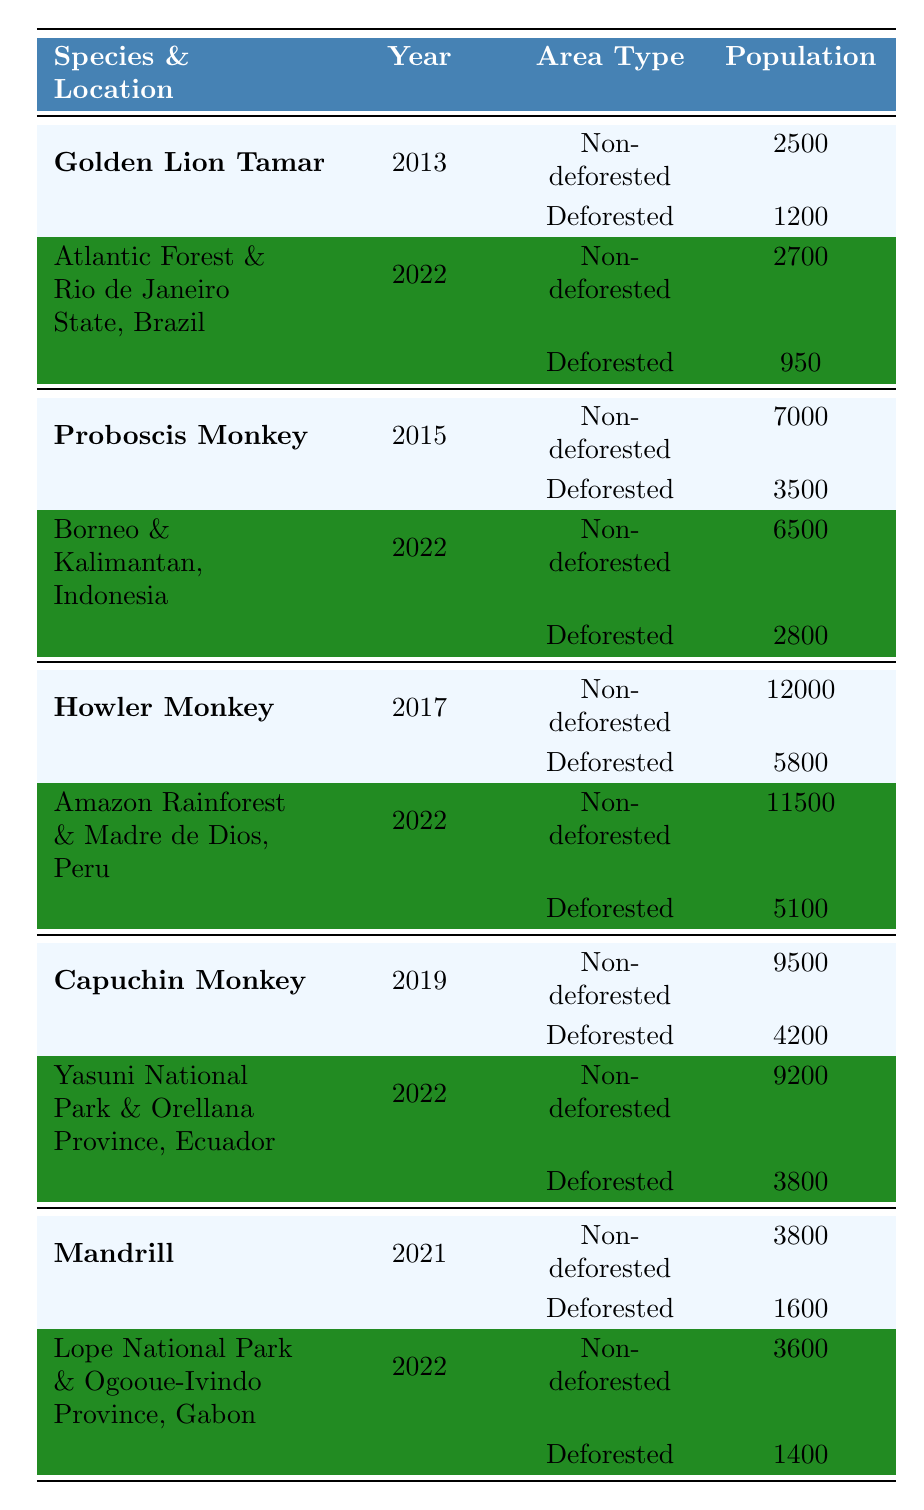What was the population count of the Golden Lion Tamarin in non-deforested areas in 2022? The table shows that in 2022, the population count of the Golden Lion Tamarin in non-deforested areas was 2700.
Answer: 2700 What is the population difference for the Howler Monkey between deforested and non-deforested areas in 2017? The population count of the Howler Monkey was 12000 in non-deforested areas and 5800 in deforested areas. The difference is 12000 - 5800 = 6200.
Answer: 6200 Did the population of Capuchin Monkeys increase or decrease from 2019 to 2022 in non-deforested areas? In non-deforested areas, the Capuchin Monkey population was 9500 in 2019 and decreased to 9200 in 2022, indicating a decrease.
Answer: Decrease Which species had the highest population count in deforested areas in 2022? The table lists the population counts of multiple species in deforested areas for 2022. The Mandrill had 1400, Capuchin Monkey had 3800, Howler Monkey had 5100, Proboscis Monkey had 2800, and Golden Lion Tamarin had 950. The highest count is 5100 for the Howler Monkey.
Answer: Howler Monkey What is the average population count for the Proboscis Monkey across all observed years? The population counts for the Proboscis Monkey are 7000 (2015), 6500 (2022), and 3500 (deforested in 2015), 2800 (deforested in 2022). For non-deforested areas, the average is (7000 + 6500) / 2 = 6750. Including deforested area counts, the average becomes (7000 + 6500 + 3500 + 2800) / 4 = 5700.
Answer: 5700 Which species has shown the least population count recorded in deforested areas during the years provided? Reviewing the table, the Mandrill has the least recorded count of 1400 in deforested areas in 2022. The other counts in deforested areas are higher.
Answer: Mandrill How many total species are represented in the table? The table features five unique species: Golden Lion Tamarin, Proboscis Monkey, Howler Monkey, Capuchin Monkey, and Mandrill.
Answer: 5 For the non-deforested population counts, which area had the highest monkey population in 2022? In 2022, the Howler Monkey population in non-deforested areas was 11500, which is the highest count listed for that year among all species.
Answer: Howler Monkey What is the trend in the population of the Golden Lion Tamarin in non-deforested areas from 2013 to 2022? In 2013, the population count was 2500, which increased to 2700 in 2022, indicating a positive trend over the years.
Answer: Increase Is there a change in the population of the Mandrill from 2021 to 2022 in deforested areas? In 2021, the Mandrill had a population count of 1600 in deforested areas, which decreased to 1400 in 2022, indicating a decline.
Answer: Yes, decrease What is the combined population count of the Howler Monkey in deforested areas across all provided years? The table indicates 5800 (2017) and 5100 (2022) in deforested areas. Therefore, the total is 5800 + 5100 = 10900.
Answer: 10900 